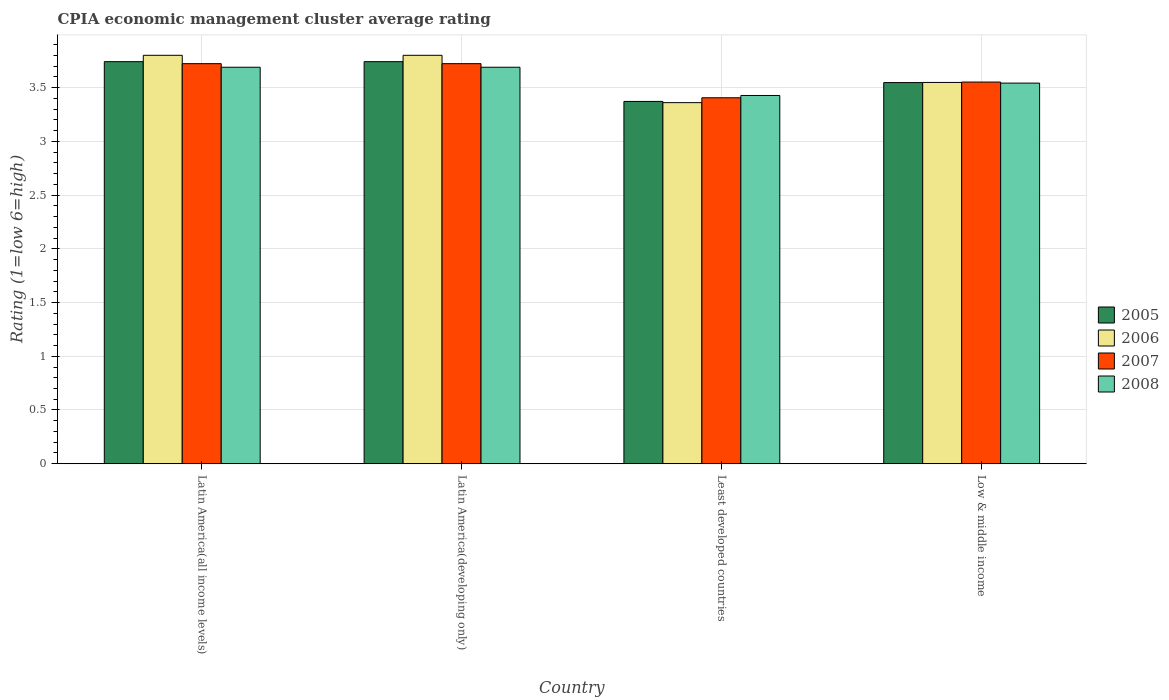How many different coloured bars are there?
Give a very brief answer. 4. Are the number of bars on each tick of the X-axis equal?
Make the answer very short. Yes. How many bars are there on the 4th tick from the left?
Your answer should be very brief. 4. What is the label of the 2nd group of bars from the left?
Offer a very short reply. Latin America(developing only). What is the CPIA rating in 2008 in Latin America(developing only)?
Make the answer very short. 3.69. Across all countries, what is the maximum CPIA rating in 2008?
Give a very brief answer. 3.69. Across all countries, what is the minimum CPIA rating in 2008?
Your response must be concise. 3.43. In which country was the CPIA rating in 2008 maximum?
Offer a terse response. Latin America(all income levels). In which country was the CPIA rating in 2007 minimum?
Keep it short and to the point. Least developed countries. What is the total CPIA rating in 2006 in the graph?
Keep it short and to the point. 14.51. What is the difference between the CPIA rating in 2007 in Latin America(developing only) and that in Least developed countries?
Your response must be concise. 0.32. What is the difference between the CPIA rating in 2007 in Latin America(developing only) and the CPIA rating in 2006 in Least developed countries?
Your answer should be compact. 0.36. What is the average CPIA rating in 2008 per country?
Ensure brevity in your answer.  3.59. What is the difference between the CPIA rating of/in 2005 and CPIA rating of/in 2008 in Latin America(all income levels)?
Keep it short and to the point. 0.05. What is the ratio of the CPIA rating in 2007 in Latin America(all income levels) to that in Least developed countries?
Provide a succinct answer. 1.09. Is the CPIA rating in 2008 in Latin America(all income levels) less than that in Latin America(developing only)?
Ensure brevity in your answer.  No. Is the difference between the CPIA rating in 2005 in Latin America(all income levels) and Low & middle income greater than the difference between the CPIA rating in 2008 in Latin America(all income levels) and Low & middle income?
Offer a very short reply. Yes. What is the difference between the highest and the second highest CPIA rating in 2007?
Your response must be concise. -0.17. What is the difference between the highest and the lowest CPIA rating in 2008?
Provide a short and direct response. 0.26. In how many countries, is the CPIA rating in 2007 greater than the average CPIA rating in 2007 taken over all countries?
Your response must be concise. 2. Is it the case that in every country, the sum of the CPIA rating in 2008 and CPIA rating in 2006 is greater than the sum of CPIA rating in 2007 and CPIA rating in 2005?
Provide a short and direct response. No. What does the 3rd bar from the right in Low & middle income represents?
Offer a very short reply. 2006. Is it the case that in every country, the sum of the CPIA rating in 2008 and CPIA rating in 2007 is greater than the CPIA rating in 2006?
Your answer should be compact. Yes. How many bars are there?
Your response must be concise. 16. Are all the bars in the graph horizontal?
Offer a terse response. No. What is the difference between two consecutive major ticks on the Y-axis?
Offer a terse response. 0.5. Are the values on the major ticks of Y-axis written in scientific E-notation?
Keep it short and to the point. No. Does the graph contain grids?
Offer a terse response. Yes. How are the legend labels stacked?
Your response must be concise. Vertical. What is the title of the graph?
Your response must be concise. CPIA economic management cluster average rating. What is the label or title of the X-axis?
Ensure brevity in your answer.  Country. What is the Rating (1=low 6=high) in 2005 in Latin America(all income levels)?
Provide a succinct answer. 3.74. What is the Rating (1=low 6=high) in 2007 in Latin America(all income levels)?
Offer a terse response. 3.72. What is the Rating (1=low 6=high) of 2008 in Latin America(all income levels)?
Ensure brevity in your answer.  3.69. What is the Rating (1=low 6=high) of 2005 in Latin America(developing only)?
Offer a very short reply. 3.74. What is the Rating (1=low 6=high) in 2006 in Latin America(developing only)?
Ensure brevity in your answer.  3.8. What is the Rating (1=low 6=high) of 2007 in Latin America(developing only)?
Give a very brief answer. 3.72. What is the Rating (1=low 6=high) in 2008 in Latin America(developing only)?
Make the answer very short. 3.69. What is the Rating (1=low 6=high) in 2005 in Least developed countries?
Your response must be concise. 3.37. What is the Rating (1=low 6=high) in 2006 in Least developed countries?
Provide a short and direct response. 3.36. What is the Rating (1=low 6=high) of 2007 in Least developed countries?
Your answer should be very brief. 3.4. What is the Rating (1=low 6=high) of 2008 in Least developed countries?
Your answer should be very brief. 3.43. What is the Rating (1=low 6=high) in 2005 in Low & middle income?
Offer a very short reply. 3.55. What is the Rating (1=low 6=high) of 2006 in Low & middle income?
Ensure brevity in your answer.  3.55. What is the Rating (1=low 6=high) in 2007 in Low & middle income?
Provide a short and direct response. 3.55. What is the Rating (1=low 6=high) of 2008 in Low & middle income?
Ensure brevity in your answer.  3.54. Across all countries, what is the maximum Rating (1=low 6=high) of 2005?
Ensure brevity in your answer.  3.74. Across all countries, what is the maximum Rating (1=low 6=high) of 2007?
Offer a very short reply. 3.72. Across all countries, what is the maximum Rating (1=low 6=high) of 2008?
Ensure brevity in your answer.  3.69. Across all countries, what is the minimum Rating (1=low 6=high) of 2005?
Offer a terse response. 3.37. Across all countries, what is the minimum Rating (1=low 6=high) in 2006?
Keep it short and to the point. 3.36. Across all countries, what is the minimum Rating (1=low 6=high) of 2007?
Give a very brief answer. 3.4. Across all countries, what is the minimum Rating (1=low 6=high) in 2008?
Make the answer very short. 3.43. What is the total Rating (1=low 6=high) of 2005 in the graph?
Make the answer very short. 14.4. What is the total Rating (1=low 6=high) of 2006 in the graph?
Offer a terse response. 14.51. What is the total Rating (1=low 6=high) of 2007 in the graph?
Give a very brief answer. 14.4. What is the total Rating (1=low 6=high) of 2008 in the graph?
Your answer should be very brief. 14.35. What is the difference between the Rating (1=low 6=high) in 2007 in Latin America(all income levels) and that in Latin America(developing only)?
Provide a succinct answer. 0. What is the difference between the Rating (1=low 6=high) in 2008 in Latin America(all income levels) and that in Latin America(developing only)?
Give a very brief answer. 0. What is the difference between the Rating (1=low 6=high) in 2005 in Latin America(all income levels) and that in Least developed countries?
Ensure brevity in your answer.  0.37. What is the difference between the Rating (1=low 6=high) in 2006 in Latin America(all income levels) and that in Least developed countries?
Your response must be concise. 0.44. What is the difference between the Rating (1=low 6=high) in 2007 in Latin America(all income levels) and that in Least developed countries?
Offer a very short reply. 0.32. What is the difference between the Rating (1=low 6=high) of 2008 in Latin America(all income levels) and that in Least developed countries?
Ensure brevity in your answer.  0.26. What is the difference between the Rating (1=low 6=high) of 2005 in Latin America(all income levels) and that in Low & middle income?
Provide a succinct answer. 0.19. What is the difference between the Rating (1=low 6=high) in 2006 in Latin America(all income levels) and that in Low & middle income?
Keep it short and to the point. 0.25. What is the difference between the Rating (1=low 6=high) in 2007 in Latin America(all income levels) and that in Low & middle income?
Offer a terse response. 0.17. What is the difference between the Rating (1=low 6=high) of 2008 in Latin America(all income levels) and that in Low & middle income?
Ensure brevity in your answer.  0.15. What is the difference between the Rating (1=low 6=high) of 2005 in Latin America(developing only) and that in Least developed countries?
Keep it short and to the point. 0.37. What is the difference between the Rating (1=low 6=high) of 2006 in Latin America(developing only) and that in Least developed countries?
Offer a terse response. 0.44. What is the difference between the Rating (1=low 6=high) of 2007 in Latin America(developing only) and that in Least developed countries?
Offer a terse response. 0.32. What is the difference between the Rating (1=low 6=high) in 2008 in Latin America(developing only) and that in Least developed countries?
Your answer should be very brief. 0.26. What is the difference between the Rating (1=low 6=high) of 2005 in Latin America(developing only) and that in Low & middle income?
Your answer should be very brief. 0.19. What is the difference between the Rating (1=low 6=high) in 2006 in Latin America(developing only) and that in Low & middle income?
Your answer should be compact. 0.25. What is the difference between the Rating (1=low 6=high) of 2007 in Latin America(developing only) and that in Low & middle income?
Ensure brevity in your answer.  0.17. What is the difference between the Rating (1=low 6=high) of 2008 in Latin America(developing only) and that in Low & middle income?
Your answer should be very brief. 0.15. What is the difference between the Rating (1=low 6=high) of 2005 in Least developed countries and that in Low & middle income?
Keep it short and to the point. -0.18. What is the difference between the Rating (1=low 6=high) in 2006 in Least developed countries and that in Low & middle income?
Give a very brief answer. -0.19. What is the difference between the Rating (1=low 6=high) of 2007 in Least developed countries and that in Low & middle income?
Your response must be concise. -0.15. What is the difference between the Rating (1=low 6=high) of 2008 in Least developed countries and that in Low & middle income?
Ensure brevity in your answer.  -0.12. What is the difference between the Rating (1=low 6=high) of 2005 in Latin America(all income levels) and the Rating (1=low 6=high) of 2006 in Latin America(developing only)?
Your response must be concise. -0.06. What is the difference between the Rating (1=low 6=high) of 2005 in Latin America(all income levels) and the Rating (1=low 6=high) of 2007 in Latin America(developing only)?
Provide a succinct answer. 0.02. What is the difference between the Rating (1=low 6=high) in 2005 in Latin America(all income levels) and the Rating (1=low 6=high) in 2008 in Latin America(developing only)?
Make the answer very short. 0.05. What is the difference between the Rating (1=low 6=high) in 2006 in Latin America(all income levels) and the Rating (1=low 6=high) in 2007 in Latin America(developing only)?
Give a very brief answer. 0.08. What is the difference between the Rating (1=low 6=high) of 2007 in Latin America(all income levels) and the Rating (1=low 6=high) of 2008 in Latin America(developing only)?
Keep it short and to the point. 0.03. What is the difference between the Rating (1=low 6=high) in 2005 in Latin America(all income levels) and the Rating (1=low 6=high) in 2006 in Least developed countries?
Your response must be concise. 0.38. What is the difference between the Rating (1=low 6=high) in 2005 in Latin America(all income levels) and the Rating (1=low 6=high) in 2007 in Least developed countries?
Ensure brevity in your answer.  0.34. What is the difference between the Rating (1=low 6=high) of 2005 in Latin America(all income levels) and the Rating (1=low 6=high) of 2008 in Least developed countries?
Provide a short and direct response. 0.31. What is the difference between the Rating (1=low 6=high) of 2006 in Latin America(all income levels) and the Rating (1=low 6=high) of 2007 in Least developed countries?
Ensure brevity in your answer.  0.4. What is the difference between the Rating (1=low 6=high) in 2006 in Latin America(all income levels) and the Rating (1=low 6=high) in 2008 in Least developed countries?
Your answer should be compact. 0.37. What is the difference between the Rating (1=low 6=high) of 2007 in Latin America(all income levels) and the Rating (1=low 6=high) of 2008 in Least developed countries?
Offer a terse response. 0.3. What is the difference between the Rating (1=low 6=high) of 2005 in Latin America(all income levels) and the Rating (1=low 6=high) of 2006 in Low & middle income?
Offer a very short reply. 0.19. What is the difference between the Rating (1=low 6=high) in 2005 in Latin America(all income levels) and the Rating (1=low 6=high) in 2007 in Low & middle income?
Keep it short and to the point. 0.19. What is the difference between the Rating (1=low 6=high) of 2005 in Latin America(all income levels) and the Rating (1=low 6=high) of 2008 in Low & middle income?
Ensure brevity in your answer.  0.2. What is the difference between the Rating (1=low 6=high) of 2006 in Latin America(all income levels) and the Rating (1=low 6=high) of 2007 in Low & middle income?
Your answer should be compact. 0.25. What is the difference between the Rating (1=low 6=high) of 2006 in Latin America(all income levels) and the Rating (1=low 6=high) of 2008 in Low & middle income?
Your answer should be compact. 0.26. What is the difference between the Rating (1=low 6=high) of 2007 in Latin America(all income levels) and the Rating (1=low 6=high) of 2008 in Low & middle income?
Provide a short and direct response. 0.18. What is the difference between the Rating (1=low 6=high) in 2005 in Latin America(developing only) and the Rating (1=low 6=high) in 2006 in Least developed countries?
Ensure brevity in your answer.  0.38. What is the difference between the Rating (1=low 6=high) in 2005 in Latin America(developing only) and the Rating (1=low 6=high) in 2007 in Least developed countries?
Your answer should be compact. 0.34. What is the difference between the Rating (1=low 6=high) of 2005 in Latin America(developing only) and the Rating (1=low 6=high) of 2008 in Least developed countries?
Ensure brevity in your answer.  0.31. What is the difference between the Rating (1=low 6=high) of 2006 in Latin America(developing only) and the Rating (1=low 6=high) of 2007 in Least developed countries?
Offer a very short reply. 0.4. What is the difference between the Rating (1=low 6=high) of 2006 in Latin America(developing only) and the Rating (1=low 6=high) of 2008 in Least developed countries?
Offer a very short reply. 0.37. What is the difference between the Rating (1=low 6=high) of 2007 in Latin America(developing only) and the Rating (1=low 6=high) of 2008 in Least developed countries?
Provide a short and direct response. 0.3. What is the difference between the Rating (1=low 6=high) of 2005 in Latin America(developing only) and the Rating (1=low 6=high) of 2006 in Low & middle income?
Provide a succinct answer. 0.19. What is the difference between the Rating (1=low 6=high) in 2005 in Latin America(developing only) and the Rating (1=low 6=high) in 2007 in Low & middle income?
Your answer should be compact. 0.19. What is the difference between the Rating (1=low 6=high) in 2005 in Latin America(developing only) and the Rating (1=low 6=high) in 2008 in Low & middle income?
Give a very brief answer. 0.2. What is the difference between the Rating (1=low 6=high) of 2006 in Latin America(developing only) and the Rating (1=low 6=high) of 2007 in Low & middle income?
Give a very brief answer. 0.25. What is the difference between the Rating (1=low 6=high) in 2006 in Latin America(developing only) and the Rating (1=low 6=high) in 2008 in Low & middle income?
Make the answer very short. 0.26. What is the difference between the Rating (1=low 6=high) of 2007 in Latin America(developing only) and the Rating (1=low 6=high) of 2008 in Low & middle income?
Provide a succinct answer. 0.18. What is the difference between the Rating (1=low 6=high) of 2005 in Least developed countries and the Rating (1=low 6=high) of 2006 in Low & middle income?
Ensure brevity in your answer.  -0.18. What is the difference between the Rating (1=low 6=high) of 2005 in Least developed countries and the Rating (1=low 6=high) of 2007 in Low & middle income?
Give a very brief answer. -0.18. What is the difference between the Rating (1=low 6=high) of 2005 in Least developed countries and the Rating (1=low 6=high) of 2008 in Low & middle income?
Your answer should be very brief. -0.17. What is the difference between the Rating (1=low 6=high) of 2006 in Least developed countries and the Rating (1=low 6=high) of 2007 in Low & middle income?
Give a very brief answer. -0.19. What is the difference between the Rating (1=low 6=high) in 2006 in Least developed countries and the Rating (1=low 6=high) in 2008 in Low & middle income?
Give a very brief answer. -0.18. What is the difference between the Rating (1=low 6=high) in 2007 in Least developed countries and the Rating (1=low 6=high) in 2008 in Low & middle income?
Your answer should be compact. -0.14. What is the average Rating (1=low 6=high) of 2005 per country?
Your answer should be very brief. 3.6. What is the average Rating (1=low 6=high) in 2006 per country?
Your answer should be very brief. 3.63. What is the average Rating (1=low 6=high) in 2007 per country?
Your response must be concise. 3.6. What is the average Rating (1=low 6=high) of 2008 per country?
Give a very brief answer. 3.59. What is the difference between the Rating (1=low 6=high) of 2005 and Rating (1=low 6=high) of 2006 in Latin America(all income levels)?
Ensure brevity in your answer.  -0.06. What is the difference between the Rating (1=low 6=high) in 2005 and Rating (1=low 6=high) in 2007 in Latin America(all income levels)?
Provide a succinct answer. 0.02. What is the difference between the Rating (1=low 6=high) of 2005 and Rating (1=low 6=high) of 2008 in Latin America(all income levels)?
Give a very brief answer. 0.05. What is the difference between the Rating (1=low 6=high) of 2006 and Rating (1=low 6=high) of 2007 in Latin America(all income levels)?
Provide a short and direct response. 0.08. What is the difference between the Rating (1=low 6=high) in 2006 and Rating (1=low 6=high) in 2008 in Latin America(all income levels)?
Keep it short and to the point. 0.11. What is the difference between the Rating (1=low 6=high) of 2005 and Rating (1=low 6=high) of 2006 in Latin America(developing only)?
Keep it short and to the point. -0.06. What is the difference between the Rating (1=low 6=high) in 2005 and Rating (1=low 6=high) in 2007 in Latin America(developing only)?
Keep it short and to the point. 0.02. What is the difference between the Rating (1=low 6=high) of 2005 and Rating (1=low 6=high) of 2008 in Latin America(developing only)?
Ensure brevity in your answer.  0.05. What is the difference between the Rating (1=low 6=high) in 2006 and Rating (1=low 6=high) in 2007 in Latin America(developing only)?
Ensure brevity in your answer.  0.08. What is the difference between the Rating (1=low 6=high) of 2007 and Rating (1=low 6=high) of 2008 in Latin America(developing only)?
Make the answer very short. 0.03. What is the difference between the Rating (1=low 6=high) in 2005 and Rating (1=low 6=high) in 2006 in Least developed countries?
Ensure brevity in your answer.  0.01. What is the difference between the Rating (1=low 6=high) of 2005 and Rating (1=low 6=high) of 2007 in Least developed countries?
Ensure brevity in your answer.  -0.03. What is the difference between the Rating (1=low 6=high) of 2005 and Rating (1=low 6=high) of 2008 in Least developed countries?
Provide a short and direct response. -0.06. What is the difference between the Rating (1=low 6=high) in 2006 and Rating (1=low 6=high) in 2007 in Least developed countries?
Offer a terse response. -0.05. What is the difference between the Rating (1=low 6=high) in 2006 and Rating (1=low 6=high) in 2008 in Least developed countries?
Make the answer very short. -0.07. What is the difference between the Rating (1=low 6=high) in 2007 and Rating (1=low 6=high) in 2008 in Least developed countries?
Keep it short and to the point. -0.02. What is the difference between the Rating (1=low 6=high) in 2005 and Rating (1=low 6=high) in 2006 in Low & middle income?
Your answer should be compact. -0. What is the difference between the Rating (1=low 6=high) in 2005 and Rating (1=low 6=high) in 2007 in Low & middle income?
Ensure brevity in your answer.  -0.01. What is the difference between the Rating (1=low 6=high) in 2005 and Rating (1=low 6=high) in 2008 in Low & middle income?
Keep it short and to the point. 0. What is the difference between the Rating (1=low 6=high) of 2006 and Rating (1=low 6=high) of 2007 in Low & middle income?
Provide a short and direct response. -0. What is the difference between the Rating (1=low 6=high) of 2006 and Rating (1=low 6=high) of 2008 in Low & middle income?
Offer a very short reply. 0.01. What is the difference between the Rating (1=low 6=high) in 2007 and Rating (1=low 6=high) in 2008 in Low & middle income?
Your answer should be compact. 0.01. What is the ratio of the Rating (1=low 6=high) in 2005 in Latin America(all income levels) to that in Latin America(developing only)?
Keep it short and to the point. 1. What is the ratio of the Rating (1=low 6=high) in 2006 in Latin America(all income levels) to that in Latin America(developing only)?
Give a very brief answer. 1. What is the ratio of the Rating (1=low 6=high) in 2008 in Latin America(all income levels) to that in Latin America(developing only)?
Provide a succinct answer. 1. What is the ratio of the Rating (1=low 6=high) in 2005 in Latin America(all income levels) to that in Least developed countries?
Give a very brief answer. 1.11. What is the ratio of the Rating (1=low 6=high) of 2006 in Latin America(all income levels) to that in Least developed countries?
Your response must be concise. 1.13. What is the ratio of the Rating (1=low 6=high) of 2007 in Latin America(all income levels) to that in Least developed countries?
Keep it short and to the point. 1.09. What is the ratio of the Rating (1=low 6=high) in 2008 in Latin America(all income levels) to that in Least developed countries?
Your answer should be very brief. 1.08. What is the ratio of the Rating (1=low 6=high) of 2005 in Latin America(all income levels) to that in Low & middle income?
Your answer should be compact. 1.05. What is the ratio of the Rating (1=low 6=high) of 2006 in Latin America(all income levels) to that in Low & middle income?
Provide a succinct answer. 1.07. What is the ratio of the Rating (1=low 6=high) in 2007 in Latin America(all income levels) to that in Low & middle income?
Keep it short and to the point. 1.05. What is the ratio of the Rating (1=low 6=high) in 2008 in Latin America(all income levels) to that in Low & middle income?
Give a very brief answer. 1.04. What is the ratio of the Rating (1=low 6=high) in 2005 in Latin America(developing only) to that in Least developed countries?
Your answer should be compact. 1.11. What is the ratio of the Rating (1=low 6=high) in 2006 in Latin America(developing only) to that in Least developed countries?
Your answer should be compact. 1.13. What is the ratio of the Rating (1=low 6=high) of 2007 in Latin America(developing only) to that in Least developed countries?
Offer a very short reply. 1.09. What is the ratio of the Rating (1=low 6=high) in 2008 in Latin America(developing only) to that in Least developed countries?
Keep it short and to the point. 1.08. What is the ratio of the Rating (1=low 6=high) of 2005 in Latin America(developing only) to that in Low & middle income?
Your response must be concise. 1.05. What is the ratio of the Rating (1=low 6=high) of 2006 in Latin America(developing only) to that in Low & middle income?
Offer a very short reply. 1.07. What is the ratio of the Rating (1=low 6=high) in 2007 in Latin America(developing only) to that in Low & middle income?
Give a very brief answer. 1.05. What is the ratio of the Rating (1=low 6=high) in 2008 in Latin America(developing only) to that in Low & middle income?
Ensure brevity in your answer.  1.04. What is the ratio of the Rating (1=low 6=high) of 2005 in Least developed countries to that in Low & middle income?
Your response must be concise. 0.95. What is the ratio of the Rating (1=low 6=high) of 2006 in Least developed countries to that in Low & middle income?
Make the answer very short. 0.95. What is the ratio of the Rating (1=low 6=high) in 2007 in Least developed countries to that in Low & middle income?
Give a very brief answer. 0.96. What is the ratio of the Rating (1=low 6=high) of 2008 in Least developed countries to that in Low & middle income?
Ensure brevity in your answer.  0.97. What is the difference between the highest and the second highest Rating (1=low 6=high) of 2007?
Make the answer very short. 0. What is the difference between the highest and the lowest Rating (1=low 6=high) of 2005?
Make the answer very short. 0.37. What is the difference between the highest and the lowest Rating (1=low 6=high) of 2006?
Your answer should be very brief. 0.44. What is the difference between the highest and the lowest Rating (1=low 6=high) in 2007?
Ensure brevity in your answer.  0.32. What is the difference between the highest and the lowest Rating (1=low 6=high) in 2008?
Provide a succinct answer. 0.26. 